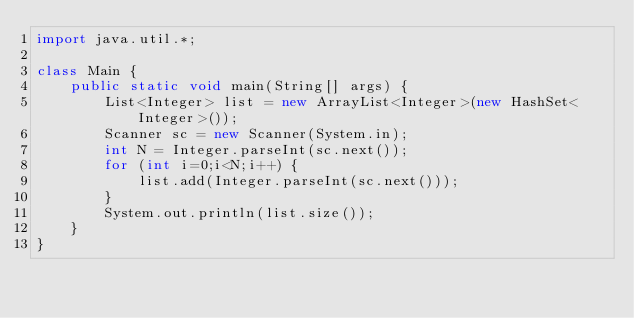Convert code to text. <code><loc_0><loc_0><loc_500><loc_500><_Java_>import java.util.*;

class Main {
    public static void main(String[] args) {
        List<Integer> list = new ArrayList<Integer>(new HashSet<Integer>());
        Scanner sc = new Scanner(System.in);
        int N = Integer.parseInt(sc.next());
        for (int i=0;i<N;i++) {
        	list.add(Integer.parseInt(sc.next()));
        }
        System.out.println(list.size());
    }
}</code> 